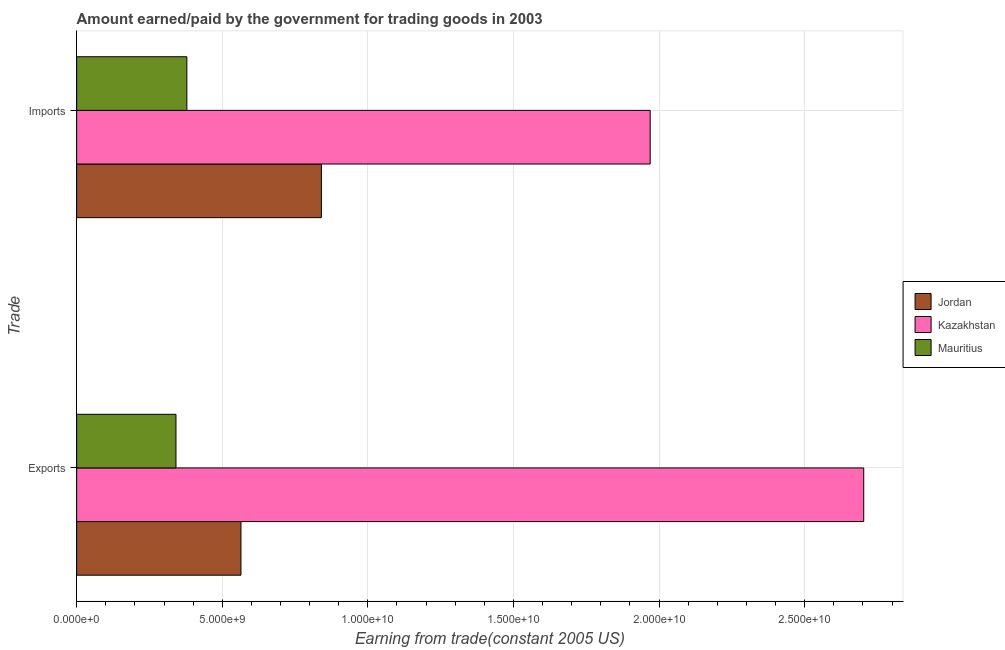Are the number of bars on each tick of the Y-axis equal?
Your response must be concise. Yes. How many bars are there on the 2nd tick from the top?
Provide a succinct answer. 3. How many bars are there on the 1st tick from the bottom?
Give a very brief answer. 3. What is the label of the 1st group of bars from the top?
Give a very brief answer. Imports. What is the amount paid for imports in Jordan?
Provide a succinct answer. 8.40e+09. Across all countries, what is the maximum amount paid for imports?
Your answer should be compact. 1.97e+1. Across all countries, what is the minimum amount earned from exports?
Your answer should be very brief. 3.41e+09. In which country was the amount earned from exports maximum?
Provide a short and direct response. Kazakhstan. In which country was the amount earned from exports minimum?
Your answer should be very brief. Mauritius. What is the total amount paid for imports in the graph?
Keep it short and to the point. 3.19e+1. What is the difference between the amount earned from exports in Jordan and that in Kazakhstan?
Ensure brevity in your answer.  -2.14e+1. What is the difference between the amount paid for imports in Jordan and the amount earned from exports in Kazakhstan?
Your answer should be very brief. -1.86e+1. What is the average amount earned from exports per country?
Offer a terse response. 1.20e+1. What is the difference between the amount earned from exports and amount paid for imports in Jordan?
Offer a terse response. -2.76e+09. In how many countries, is the amount earned from exports greater than 24000000000 US$?
Keep it short and to the point. 1. What is the ratio of the amount earned from exports in Mauritius to that in Jordan?
Your response must be concise. 0.6. What does the 3rd bar from the top in Exports represents?
Ensure brevity in your answer.  Jordan. What does the 2nd bar from the bottom in Exports represents?
Your answer should be compact. Kazakhstan. Are all the bars in the graph horizontal?
Ensure brevity in your answer.  Yes. What is the difference between two consecutive major ticks on the X-axis?
Offer a very short reply. 5.00e+09. Are the values on the major ticks of X-axis written in scientific E-notation?
Give a very brief answer. Yes. How many legend labels are there?
Your response must be concise. 3. What is the title of the graph?
Offer a very short reply. Amount earned/paid by the government for trading goods in 2003. Does "Oman" appear as one of the legend labels in the graph?
Your response must be concise. No. What is the label or title of the X-axis?
Give a very brief answer. Earning from trade(constant 2005 US). What is the label or title of the Y-axis?
Your response must be concise. Trade. What is the Earning from trade(constant 2005 US) in Jordan in Exports?
Provide a short and direct response. 5.64e+09. What is the Earning from trade(constant 2005 US) in Kazakhstan in Exports?
Ensure brevity in your answer.  2.70e+1. What is the Earning from trade(constant 2005 US) of Mauritius in Exports?
Your response must be concise. 3.41e+09. What is the Earning from trade(constant 2005 US) in Jordan in Imports?
Offer a terse response. 8.40e+09. What is the Earning from trade(constant 2005 US) in Kazakhstan in Imports?
Ensure brevity in your answer.  1.97e+1. What is the Earning from trade(constant 2005 US) of Mauritius in Imports?
Ensure brevity in your answer.  3.78e+09. Across all Trade, what is the maximum Earning from trade(constant 2005 US) of Jordan?
Keep it short and to the point. 8.40e+09. Across all Trade, what is the maximum Earning from trade(constant 2005 US) in Kazakhstan?
Provide a succinct answer. 2.70e+1. Across all Trade, what is the maximum Earning from trade(constant 2005 US) of Mauritius?
Offer a very short reply. 3.78e+09. Across all Trade, what is the minimum Earning from trade(constant 2005 US) of Jordan?
Provide a short and direct response. 5.64e+09. Across all Trade, what is the minimum Earning from trade(constant 2005 US) in Kazakhstan?
Give a very brief answer. 1.97e+1. Across all Trade, what is the minimum Earning from trade(constant 2005 US) of Mauritius?
Your response must be concise. 3.41e+09. What is the total Earning from trade(constant 2005 US) in Jordan in the graph?
Your answer should be compact. 1.40e+1. What is the total Earning from trade(constant 2005 US) of Kazakhstan in the graph?
Offer a very short reply. 4.67e+1. What is the total Earning from trade(constant 2005 US) of Mauritius in the graph?
Your response must be concise. 7.20e+09. What is the difference between the Earning from trade(constant 2005 US) in Jordan in Exports and that in Imports?
Give a very brief answer. -2.76e+09. What is the difference between the Earning from trade(constant 2005 US) of Kazakhstan in Exports and that in Imports?
Ensure brevity in your answer.  7.33e+09. What is the difference between the Earning from trade(constant 2005 US) of Mauritius in Exports and that in Imports?
Make the answer very short. -3.73e+08. What is the difference between the Earning from trade(constant 2005 US) of Jordan in Exports and the Earning from trade(constant 2005 US) of Kazakhstan in Imports?
Your answer should be compact. -1.41e+1. What is the difference between the Earning from trade(constant 2005 US) of Jordan in Exports and the Earning from trade(constant 2005 US) of Mauritius in Imports?
Offer a very short reply. 1.86e+09. What is the difference between the Earning from trade(constant 2005 US) of Kazakhstan in Exports and the Earning from trade(constant 2005 US) of Mauritius in Imports?
Keep it short and to the point. 2.32e+1. What is the average Earning from trade(constant 2005 US) in Jordan per Trade?
Provide a succinct answer. 7.02e+09. What is the average Earning from trade(constant 2005 US) of Kazakhstan per Trade?
Your answer should be compact. 2.34e+1. What is the average Earning from trade(constant 2005 US) in Mauritius per Trade?
Provide a succinct answer. 3.60e+09. What is the difference between the Earning from trade(constant 2005 US) of Jordan and Earning from trade(constant 2005 US) of Kazakhstan in Exports?
Ensure brevity in your answer.  -2.14e+1. What is the difference between the Earning from trade(constant 2005 US) in Jordan and Earning from trade(constant 2005 US) in Mauritius in Exports?
Your answer should be very brief. 2.23e+09. What is the difference between the Earning from trade(constant 2005 US) of Kazakhstan and Earning from trade(constant 2005 US) of Mauritius in Exports?
Provide a short and direct response. 2.36e+1. What is the difference between the Earning from trade(constant 2005 US) of Jordan and Earning from trade(constant 2005 US) of Kazakhstan in Imports?
Your answer should be very brief. -1.13e+1. What is the difference between the Earning from trade(constant 2005 US) in Jordan and Earning from trade(constant 2005 US) in Mauritius in Imports?
Provide a short and direct response. 4.62e+09. What is the difference between the Earning from trade(constant 2005 US) of Kazakhstan and Earning from trade(constant 2005 US) of Mauritius in Imports?
Your answer should be very brief. 1.59e+1. What is the ratio of the Earning from trade(constant 2005 US) in Jordan in Exports to that in Imports?
Provide a succinct answer. 0.67. What is the ratio of the Earning from trade(constant 2005 US) of Kazakhstan in Exports to that in Imports?
Make the answer very short. 1.37. What is the ratio of the Earning from trade(constant 2005 US) in Mauritius in Exports to that in Imports?
Make the answer very short. 0.9. What is the difference between the highest and the second highest Earning from trade(constant 2005 US) of Jordan?
Offer a terse response. 2.76e+09. What is the difference between the highest and the second highest Earning from trade(constant 2005 US) in Kazakhstan?
Keep it short and to the point. 7.33e+09. What is the difference between the highest and the second highest Earning from trade(constant 2005 US) of Mauritius?
Provide a succinct answer. 3.73e+08. What is the difference between the highest and the lowest Earning from trade(constant 2005 US) in Jordan?
Keep it short and to the point. 2.76e+09. What is the difference between the highest and the lowest Earning from trade(constant 2005 US) in Kazakhstan?
Your response must be concise. 7.33e+09. What is the difference between the highest and the lowest Earning from trade(constant 2005 US) of Mauritius?
Your response must be concise. 3.73e+08. 